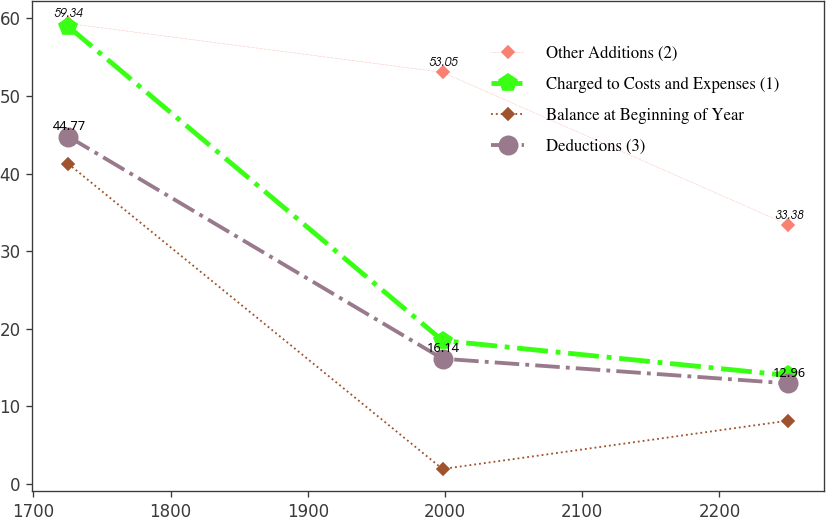Convert chart to OTSL. <chart><loc_0><loc_0><loc_500><loc_500><line_chart><ecel><fcel>Other Additions (2)<fcel>Charged to Costs and Expenses (1)<fcel>Balance at Beginning of Year<fcel>Deductions (3)<nl><fcel>1725.35<fcel>59.34<fcel>58.94<fcel>41.26<fcel>44.77<nl><fcel>1998.15<fcel>53.05<fcel>18.48<fcel>1.93<fcel>16.14<nl><fcel>2250.25<fcel>33.38<fcel>13.98<fcel>8.16<fcel>12.96<nl></chart> 